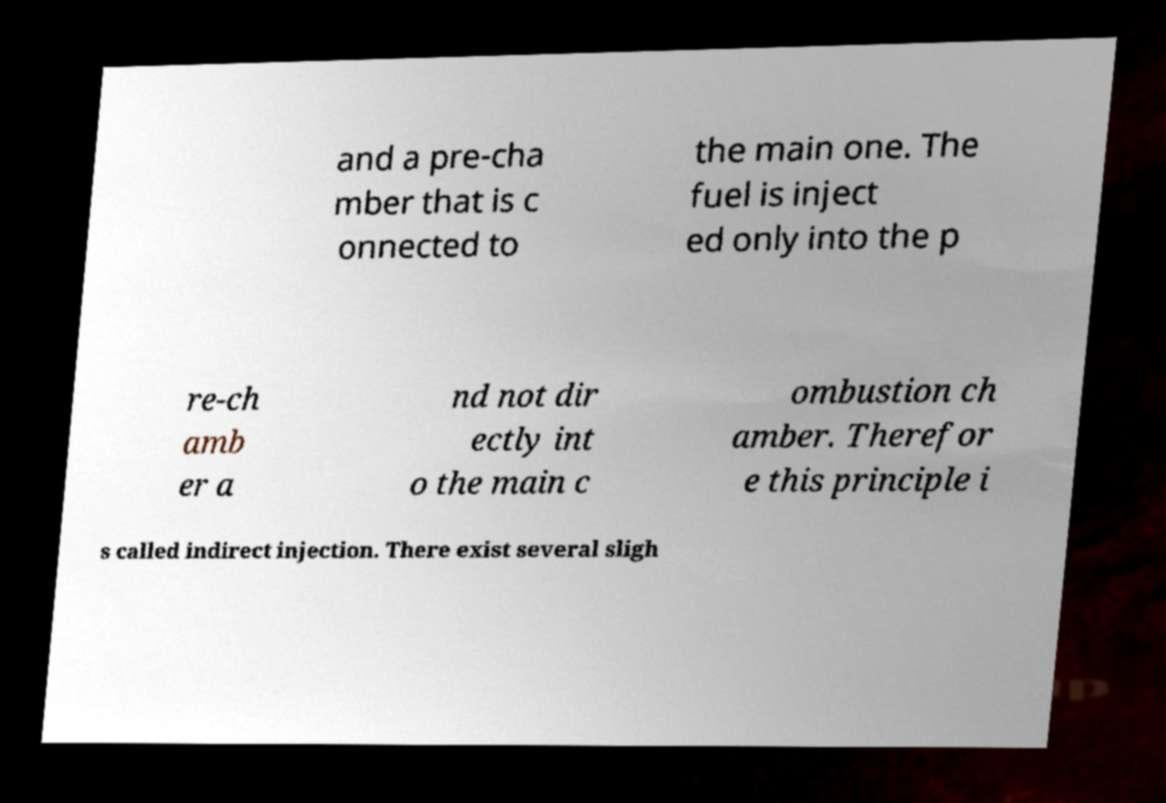Could you extract and type out the text from this image? and a pre-cha mber that is c onnected to the main one. The fuel is inject ed only into the p re-ch amb er a nd not dir ectly int o the main c ombustion ch amber. Therefor e this principle i s called indirect injection. There exist several sligh 